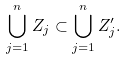Convert formula to latex. <formula><loc_0><loc_0><loc_500><loc_500>\bigcup _ { j = 1 } ^ { n } Z _ { j } \subset \bigcup _ { j = 1 } ^ { n } Z _ { j } ^ { \prime } .</formula> 